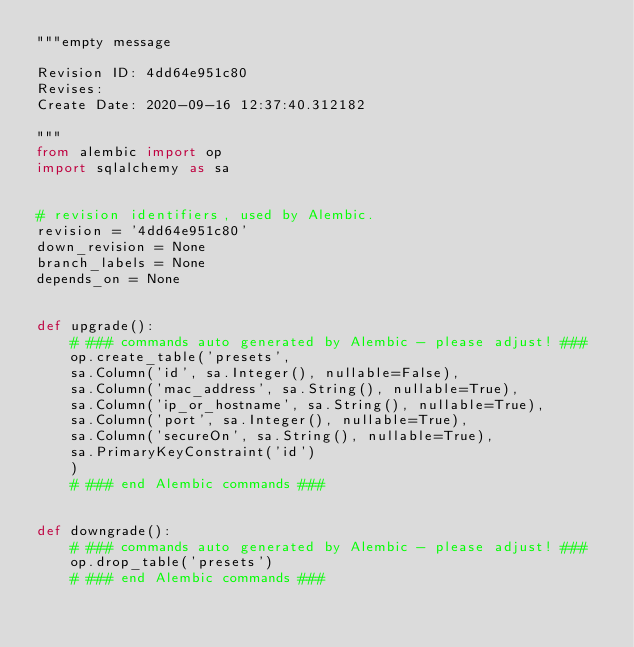<code> <loc_0><loc_0><loc_500><loc_500><_Python_>"""empty message

Revision ID: 4dd64e951c80
Revises: 
Create Date: 2020-09-16 12:37:40.312182

"""
from alembic import op
import sqlalchemy as sa


# revision identifiers, used by Alembic.
revision = '4dd64e951c80'
down_revision = None
branch_labels = None
depends_on = None


def upgrade():
    # ### commands auto generated by Alembic - please adjust! ###
    op.create_table('presets',
    sa.Column('id', sa.Integer(), nullable=False),
    sa.Column('mac_address', sa.String(), nullable=True),
    sa.Column('ip_or_hostname', sa.String(), nullable=True),
    sa.Column('port', sa.Integer(), nullable=True),
    sa.Column('secureOn', sa.String(), nullable=True),
    sa.PrimaryKeyConstraint('id')
    )
    # ### end Alembic commands ###


def downgrade():
    # ### commands auto generated by Alembic - please adjust! ###
    op.drop_table('presets')
    # ### end Alembic commands ###
</code> 